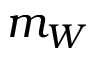Convert formula to latex. <formula><loc_0><loc_0><loc_500><loc_500>m _ { W }</formula> 